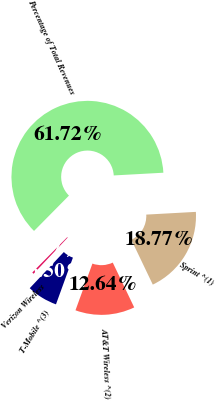<chart> <loc_0><loc_0><loc_500><loc_500><pie_chart><fcel>Percentage of Total Revenues<fcel>Sprint ^(1)<fcel>AT&T Wireless ^(2)<fcel>T-Mobile ^(3)<fcel>Verizon Wireless<nl><fcel>61.72%<fcel>18.77%<fcel>12.64%<fcel>6.5%<fcel>0.37%<nl></chart> 